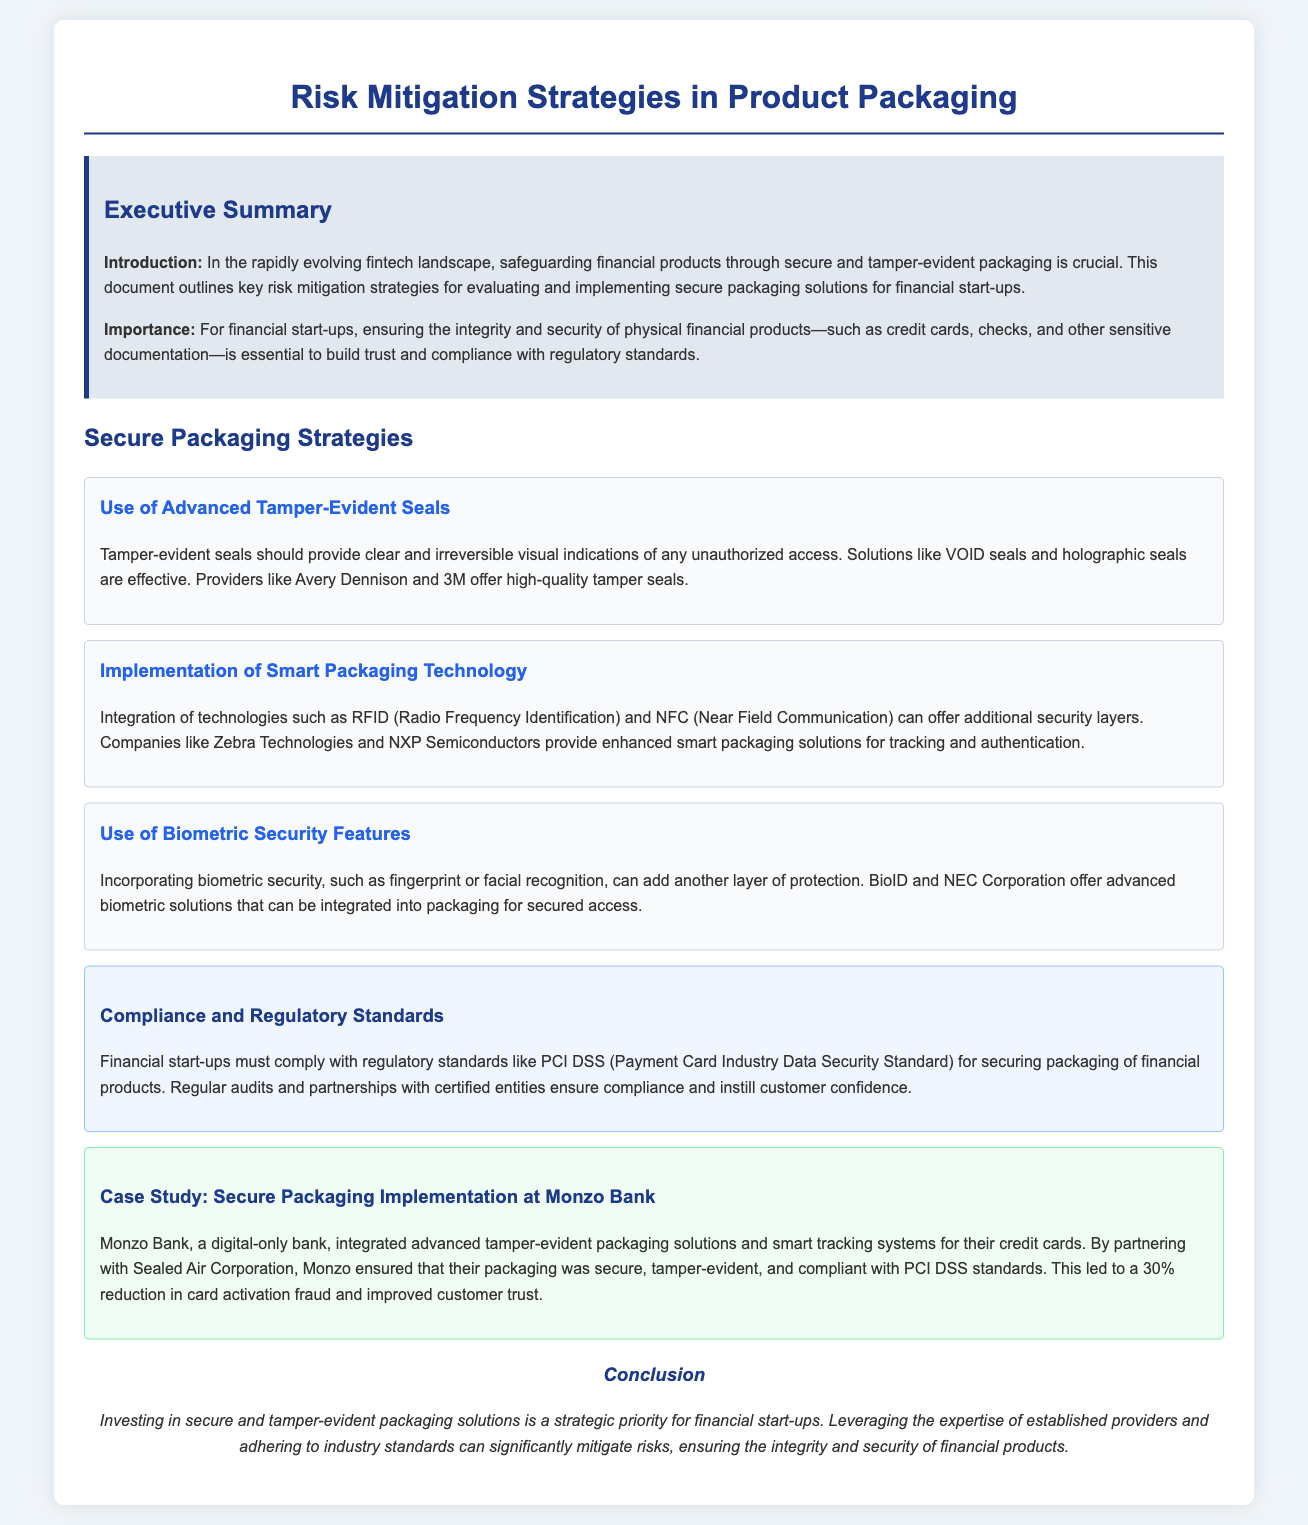What is the title of the document? The title is stated in the header of the document, summarizing its purpose.
Answer: Risk Mitigation Strategies in Product Packaging Who provides advanced tamper-evident seals? The document lists specific providers for tamper-evident seals, indicating their relevance and expertise.
Answer: Avery Dennison and 3M What technology can be integrated for additional security layers? The document mentions specific technologies that enhance security in packaging solutions.
Answer: RFID and NFC What financial standard must be complied with? The compliance section of the document specifies a key regulatory standard applicable to financial start-ups.
Answer: PCI DSS What was the percentage reduction in card activation fraud at Monzo Bank? The case study provides a specific figure related to the outcomes of implementing secure packaging solutions.
Answer: 30% What is the purpose of investing in secure packaging solutions? The conclusion encapsulates the strategic importance of secure packaging for financial start-ups.
Answer: Strategic priority Which company partnered with Monzo Bank for packaging solutions? The case study specifies a corporation that provided tamper-evident and compliant packaging.
Answer: Sealed Air Corporation What is a biometric security feature mentioned in the document? The document highlights specific biometric technologies that are integrated into packaging for security purposes.
Answer: Fingerprint or facial recognition What color is used for the executive summary background? The document describes a specific color used for the background of the executive summary section, enhancing its visual importance.
Answer: Light gray 